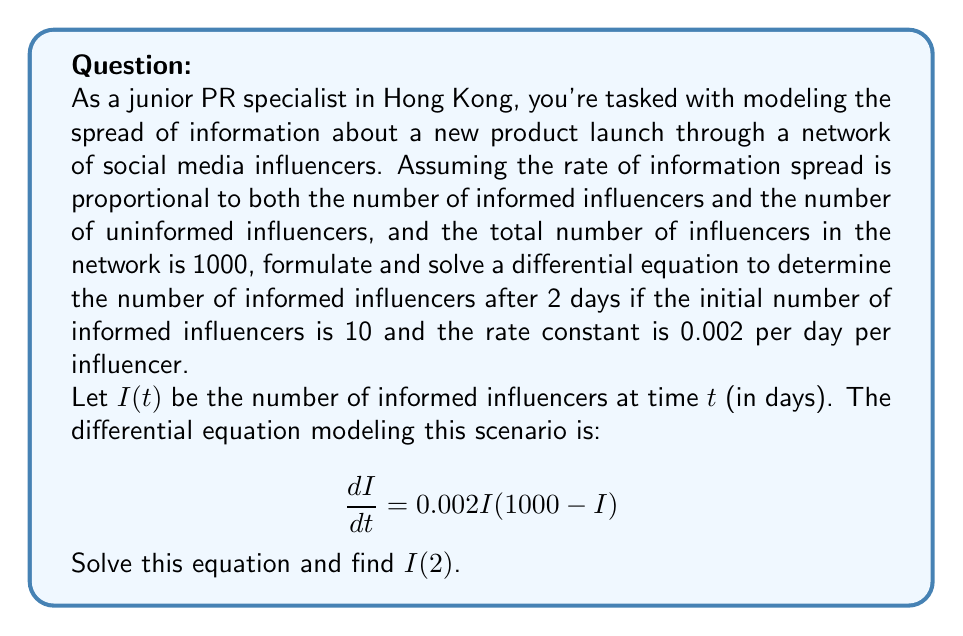Show me your answer to this math problem. Let's solve this problem step by step:

1) The given differential equation is:

   $$\frac{dI}{dt} = 0.002I(1000-I)$$

2) This is a separable equation. Let's rearrange it:

   $$\frac{dI}{I(1000-I)} = 0.002dt$$

3) Integrate both sides:

   $$\int \frac{dI}{I(1000-I)} = \int 0.002dt$$

4) The left side can be integrated using partial fractions:

   $$\frac{1}{1000}\ln|I| - \frac{1}{1000}\ln|1000-I| = 0.002t + C$$

5) Simplify:

   $$\ln|\frac{I}{1000-I}| = 2t + C'$$

6) Take exponential of both sides:

   $$\frac{I}{1000-I} = Ae^{2t}$$, where $A = e^{C'}$

7) Solve for $I$:

   $$I = \frac{1000Ae^{2t}}{1+Ae^{2t}}$$

8) Use the initial condition $I(0) = 10$ to find $A$:

   $$10 = \frac{1000A}{1+A}$$
   $$A = \frac{1}{99}$$

9) Therefore, the solution is:

   $$I(t) = \frac{1000(\frac{1}{99})e^{2t}}{1+(\frac{1}{99})e^{2t}} = \frac{1000e^{2t}}{99+e^{2t}}$$

10) To find $I(2)$, substitute $t=2$:

    $$I(2) = \frac{1000e^{4}}{99+e^{4}} \approx 544.27$$

11) Since we're dealing with whole influencers, we round down to 544.
Answer: 544 informed influencers after 2 days 